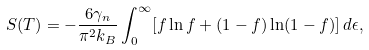<formula> <loc_0><loc_0><loc_500><loc_500>S ( T ) = - \frac { 6 \gamma _ { n } } { \pi ^ { 2 } k _ { B } } \int ^ { \infty } _ { 0 } [ f \ln f + ( 1 - f ) \ln ( 1 - f ) ] \, d \epsilon ,</formula> 